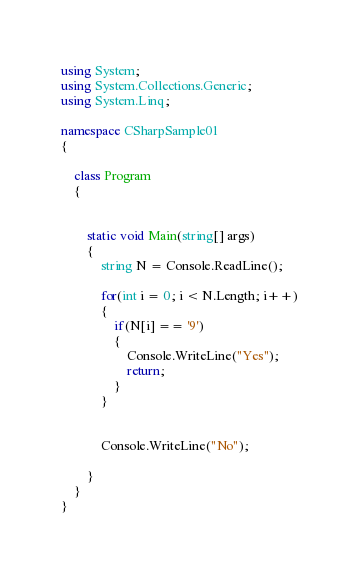Convert code to text. <code><loc_0><loc_0><loc_500><loc_500><_C#_>using System;
using System.Collections.Generic;
using System.Linq;

namespace CSharpSample01
{
    
    class Program
    {
        

        static void Main(string[] args)
        {
            string N = Console.ReadLine();

            for(int i = 0; i < N.Length; i++)
            {
                if(N[i] == '9')
                {
                    Console.WriteLine("Yes");
                    return;
                }
            }


            Console.WriteLine("No");
            
        }
    }
}</code> 